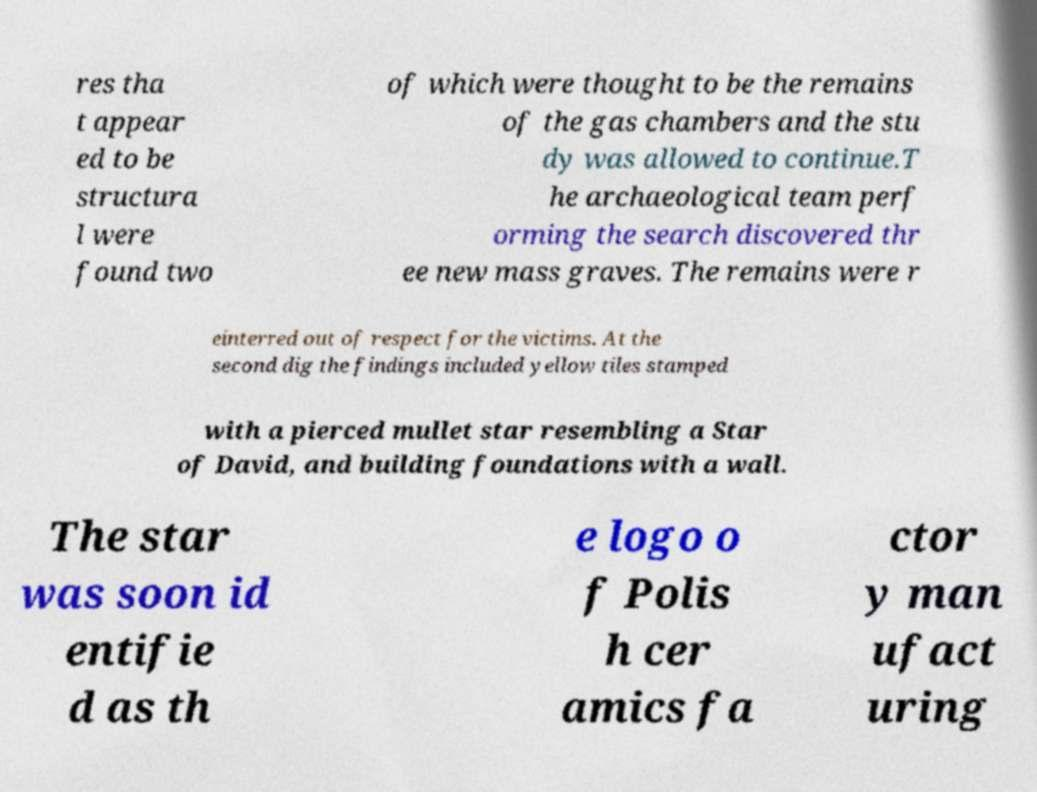Could you assist in decoding the text presented in this image and type it out clearly? res tha t appear ed to be structura l were found two of which were thought to be the remains of the gas chambers and the stu dy was allowed to continue.T he archaeological team perf orming the search discovered thr ee new mass graves. The remains were r einterred out of respect for the victims. At the second dig the findings included yellow tiles stamped with a pierced mullet star resembling a Star of David, and building foundations with a wall. The star was soon id entifie d as th e logo o f Polis h cer amics fa ctor y man ufact uring 